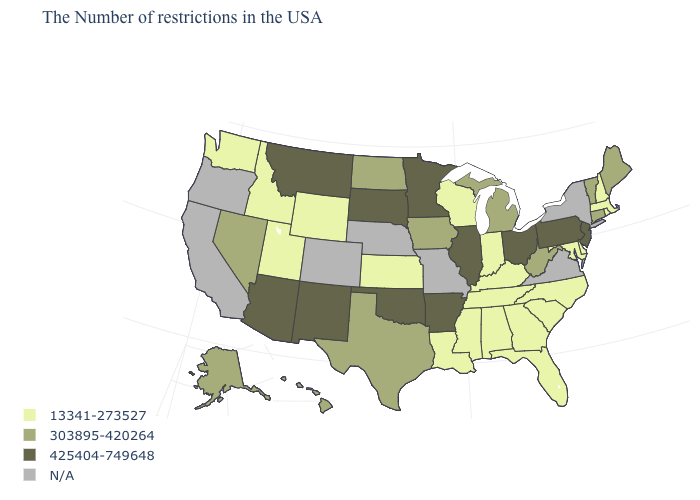Does the first symbol in the legend represent the smallest category?
Short answer required. Yes. Among the states that border Minnesota , which have the highest value?
Write a very short answer. South Dakota. Name the states that have a value in the range 13341-273527?
Be succinct. Massachusetts, Rhode Island, New Hampshire, Delaware, Maryland, North Carolina, South Carolina, Florida, Georgia, Kentucky, Indiana, Alabama, Tennessee, Wisconsin, Mississippi, Louisiana, Kansas, Wyoming, Utah, Idaho, Washington. Which states hav the highest value in the West?
Keep it brief. New Mexico, Montana, Arizona. Which states have the highest value in the USA?
Keep it brief. New Jersey, Pennsylvania, Ohio, Illinois, Arkansas, Minnesota, Oklahoma, South Dakota, New Mexico, Montana, Arizona. Among the states that border Montana , which have the highest value?
Write a very short answer. South Dakota. Does the map have missing data?
Write a very short answer. Yes. What is the lowest value in states that border Rhode Island?
Answer briefly. 13341-273527. What is the value of Hawaii?
Give a very brief answer. 303895-420264. Name the states that have a value in the range 425404-749648?
Quick response, please. New Jersey, Pennsylvania, Ohio, Illinois, Arkansas, Minnesota, Oklahoma, South Dakota, New Mexico, Montana, Arizona. What is the highest value in the West ?
Keep it brief. 425404-749648. Name the states that have a value in the range N/A?
Give a very brief answer. New York, Virginia, Missouri, Nebraska, Colorado, California, Oregon. Does Minnesota have the lowest value in the USA?
Keep it brief. No. What is the value of Maryland?
Answer briefly. 13341-273527. 